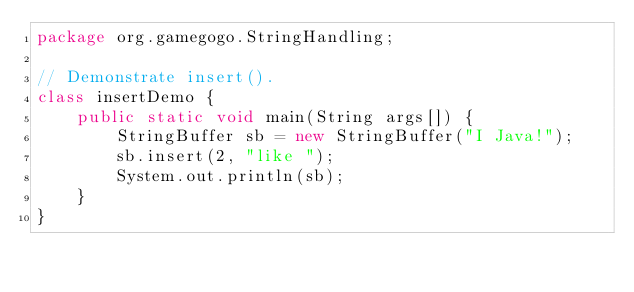<code> <loc_0><loc_0><loc_500><loc_500><_Java_>package org.gamegogo.StringHandling;

// Demonstrate insert().
class insertDemo {
    public static void main(String args[]) {
        StringBuffer sb = new StringBuffer("I Java!");
        sb.insert(2, "like ");
        System.out.println(sb);
    }
}
</code> 